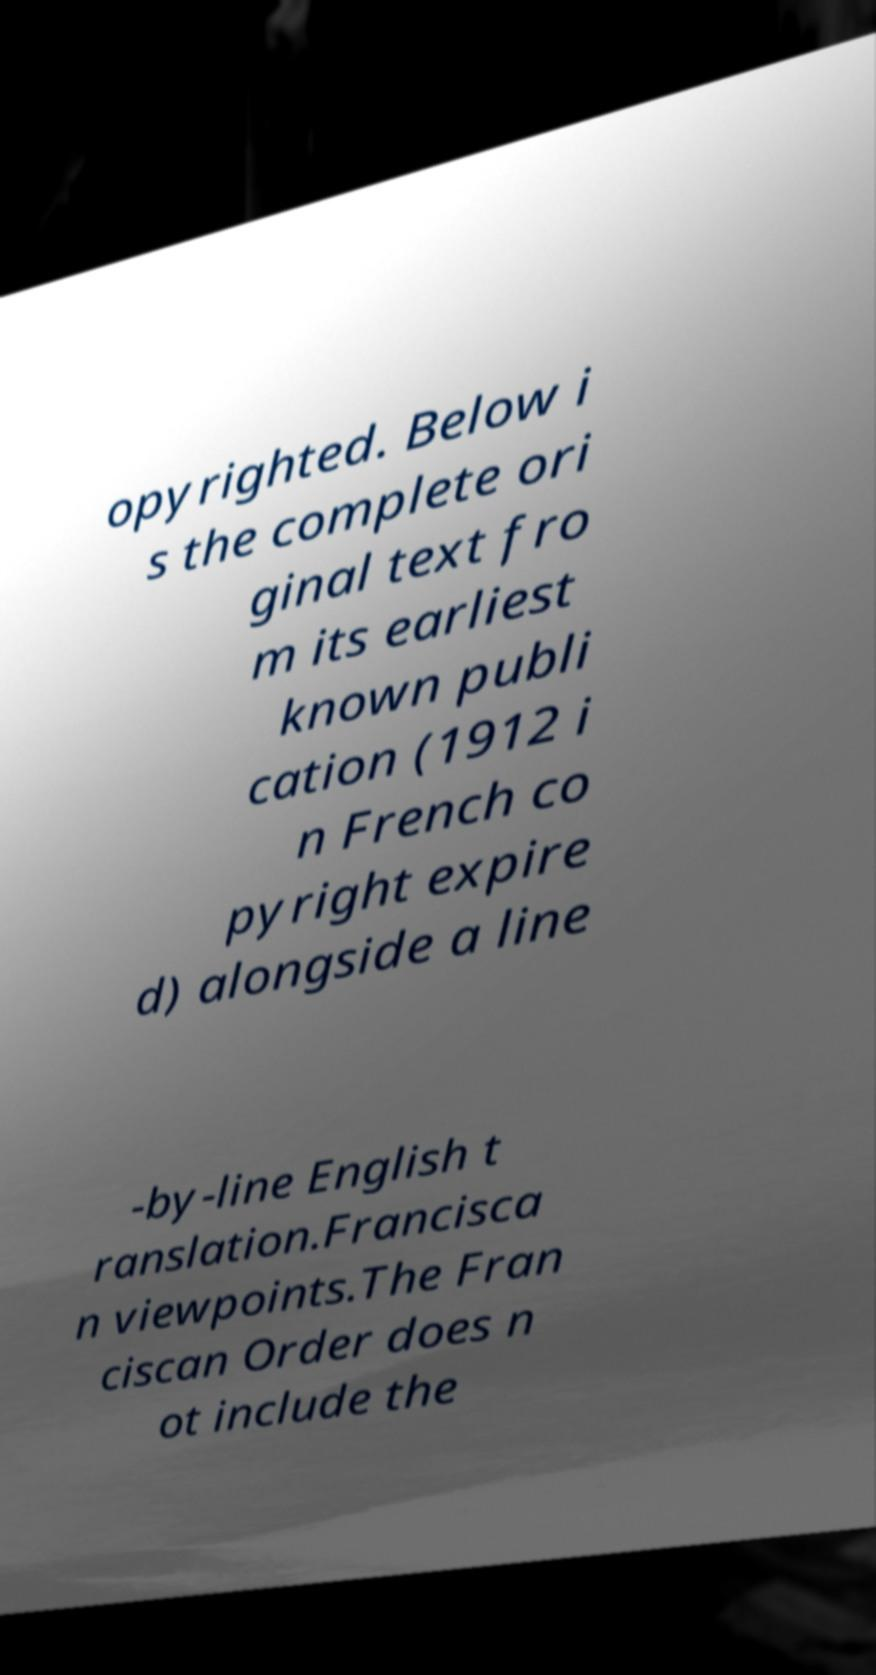Can you read and provide the text displayed in the image?This photo seems to have some interesting text. Can you extract and type it out for me? opyrighted. Below i s the complete ori ginal text fro m its earliest known publi cation (1912 i n French co pyright expire d) alongside a line -by-line English t ranslation.Francisca n viewpoints.The Fran ciscan Order does n ot include the 